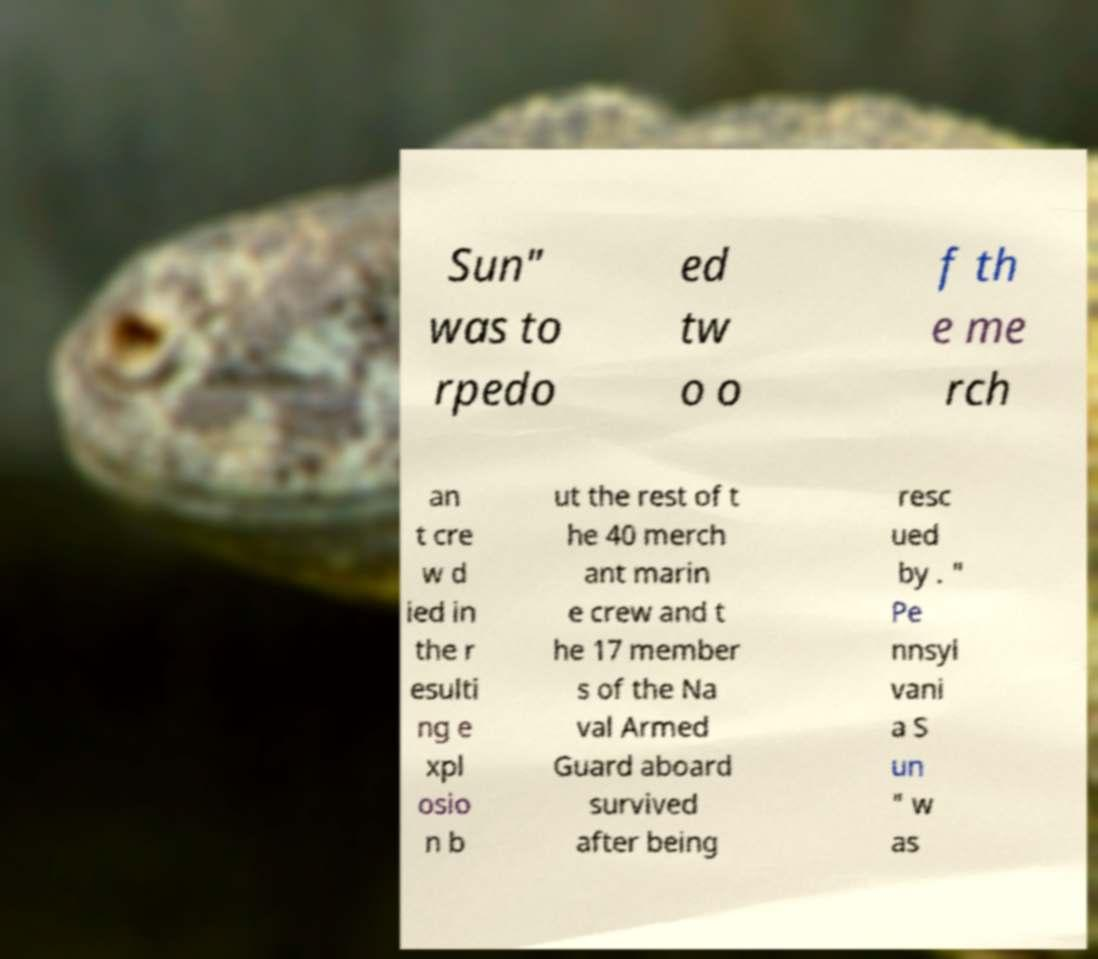Please identify and transcribe the text found in this image. Sun" was to rpedo ed tw o o f th e me rch an t cre w d ied in the r esulti ng e xpl osio n b ut the rest of t he 40 merch ant marin e crew and t he 17 member s of the Na val Armed Guard aboard survived after being resc ued by . " Pe nnsyl vani a S un " w as 